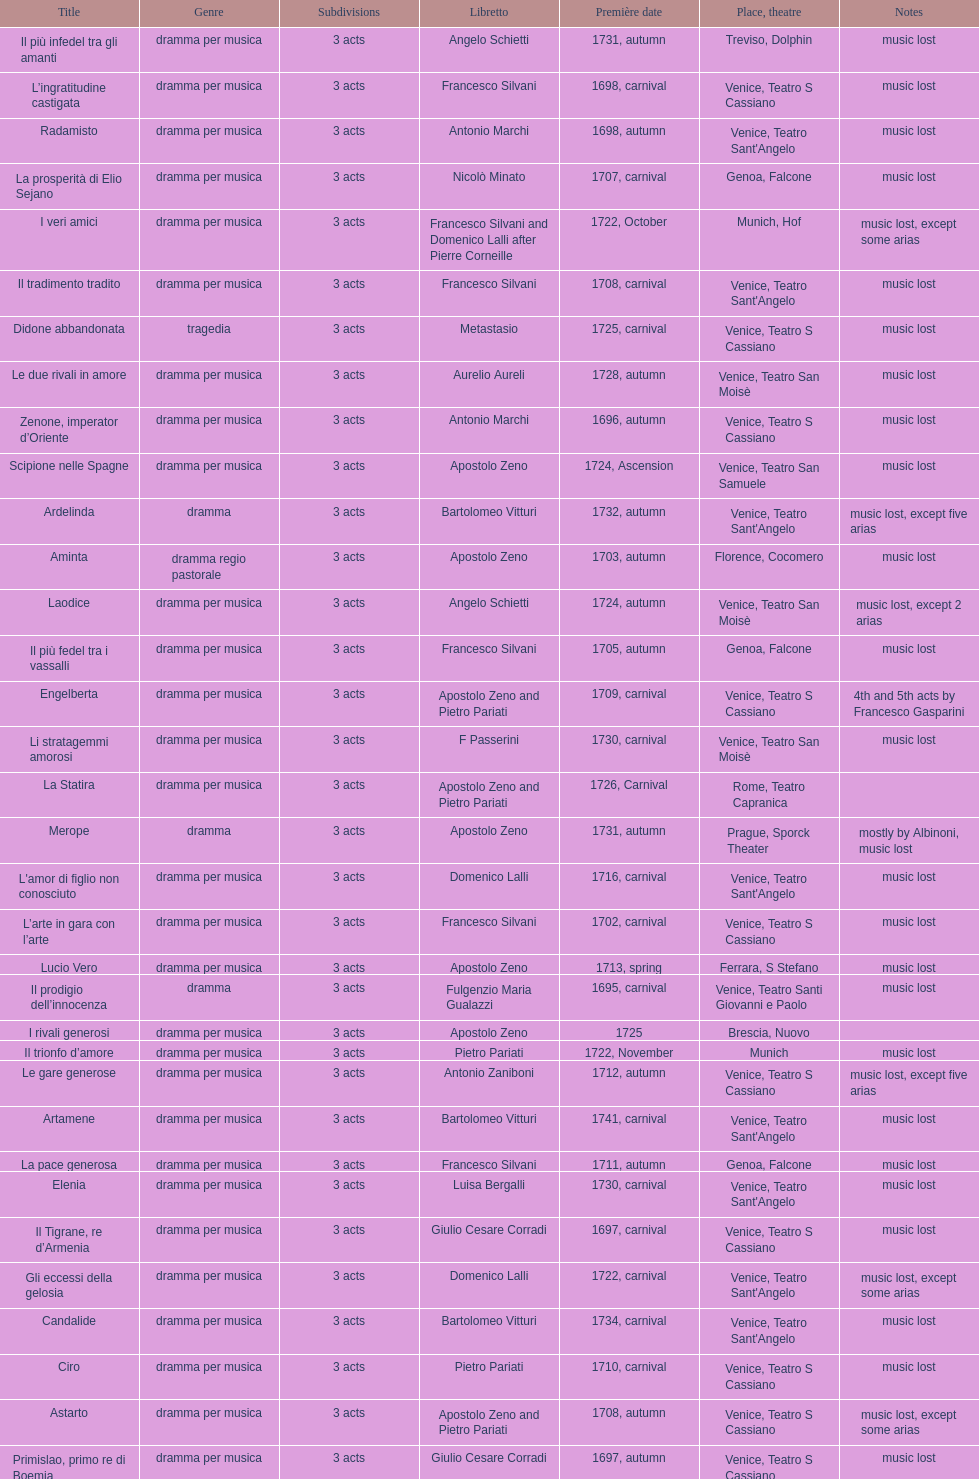L'inganno innocente premiered in 1701. what was the previous title released? Diomede punito da Alcide. 